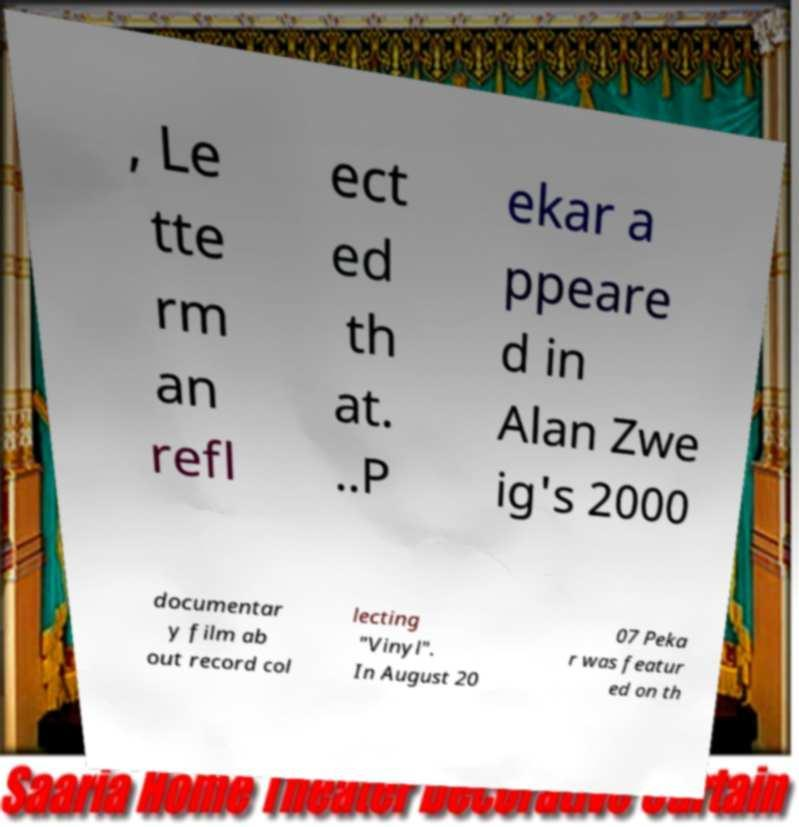Please read and relay the text visible in this image. What does it say? , Le tte rm an refl ect ed th at. ..P ekar a ppeare d in Alan Zwe ig's 2000 documentar y film ab out record col lecting "Vinyl". In August 20 07 Peka r was featur ed on th 